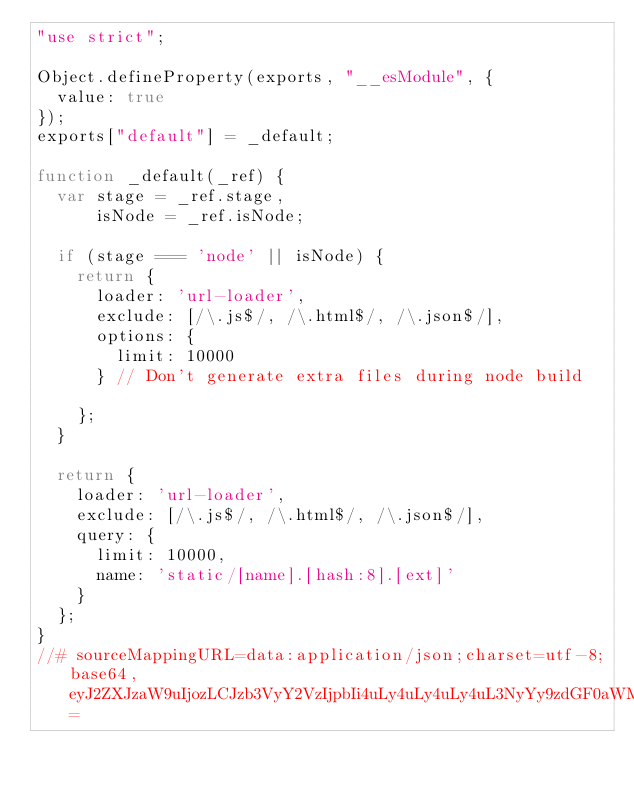Convert code to text. <code><loc_0><loc_0><loc_500><loc_500><_JavaScript_>"use strict";

Object.defineProperty(exports, "__esModule", {
  value: true
});
exports["default"] = _default;

function _default(_ref) {
  var stage = _ref.stage,
      isNode = _ref.isNode;

  if (stage === 'node' || isNode) {
    return {
      loader: 'url-loader',
      exclude: [/\.js$/, /\.html$/, /\.json$/],
      options: {
        limit: 10000
      } // Don't generate extra files during node build

    };
  }

  return {
    loader: 'url-loader',
    exclude: [/\.js$/, /\.html$/, /\.json$/],
    query: {
      limit: 10000,
      name: 'static/[name].[hash:8].[ext]'
    }
  };
}
//# sourceMappingURL=data:application/json;charset=utf-8;base64,eyJ2ZXJzaW9uIjozLCJzb3VyY2VzIjpbIi4uLy4uLy4uLy4uL3NyYy9zdGF0aWMvd2VicGFjay9ydWxlcy9maWxlTG9hZGVyLmpzIl0sIm5hbWVzIjpbInN0YWdlIiwiaXNOb2RlIiwibG9hZGVyIiwiZXhjbHVkZSIsIm9wdGlvbnMiLCJsaW1pdCIsInF1ZXJ5IiwibmFtZSJdLCJtYXBwaW5ncyI6Ijs7Ozs7OztBQUFlLHdCQUE0QjtBQUFBLE1BQWpCQSxLQUFpQixRQUFqQkEsS0FBaUI7QUFBQSxNQUFWQyxNQUFVLFFBQVZBLE1BQVU7O0FBQ3pDLE1BQUlELEtBQUssS0FBSyxNQUFWLElBQW9CQyxNQUF4QixFQUFnQztBQUM5QixXQUFPO0FBQ0xDLE1BQUFBLE1BQU0sRUFBRSxZQURIO0FBRUxDLE1BQUFBLE9BQU8sRUFBRSxDQUFDLE9BQUQsRUFBVSxTQUFWLEVBQXFCLFNBQXJCLENBRko7QUFHTEMsTUFBQUEsT0FBTyxFQUFFO0FBQ1BDLFFBQUFBLEtBQUssRUFBRTtBQURBLE9BSEosQ0FNTDs7QUFOSyxLQUFQO0FBUUQ7O0FBQ0QsU0FBTztBQUNMSCxJQUFBQSxNQUFNLEVBQUUsWUFESDtBQUVMQyxJQUFBQSxPQUFPLEVBQUUsQ0FBQyxPQUFELEVBQVUsU0FBVixFQUFxQixTQUFyQixDQUZKO0FBR0xHLElBQUFBLEtBQUssRUFBRTtBQUNMRCxNQUFBQSxLQUFLLEVBQUUsS0FERjtBQUVMRSxNQUFBQSxJQUFJLEVBQUU7QUFGRDtBQUhGLEdBQVA7QUFRRCIsInNvdXJjZXNDb250ZW50IjpbImV4cG9ydCBkZWZhdWx0IGZ1bmN0aW9uKHsgc3RhZ2UsIGlzTm9kZSB9KSB7XG4gIGlmIChzdGFnZSA9PT0gJ25vZGUnIHx8IGlzTm9kZSkge1xuICAgIHJldHVybiB7XG4gICAgICBsb2FkZXI6ICd1cmwtbG9hZGVyJyxcbiAgICAgIGV4Y2x1ZGU6IFsvXFwuanMkLywgL1xcLmh0bWwkLywgL1xcLmpzb24kL10sXG4gICAgICBvcHRpb25zOiB7XG4gICAgICAgIGxpbWl0OiAxMDAwMCxcbiAgICAgIH0sXG4gICAgICAvLyBEb24ndCBnZW5lcmF0ZSBleHRyYSBmaWxlcyBkdXJpbmcgbm9kZSBidWlsZFxuICAgIH1cbiAgfVxuICByZXR1cm4ge1xuICAgIGxvYWRlcjogJ3VybC1sb2FkZXInLFxuICAgIGV4Y2x1ZGU6IFsvXFwuanMkLywgL1xcLmh0bWwkLywgL1xcLmpzb24kL10sXG4gICAgcXVlcnk6IHtcbiAgICAgIGxpbWl0OiAxMDAwMCxcbiAgICAgIG5hbWU6ICdzdGF0aWMvW25hbWVdLltoYXNoOjhdLltleHRdJyxcbiAgICB9LFxuICB9XG59XG4iXX0=</code> 